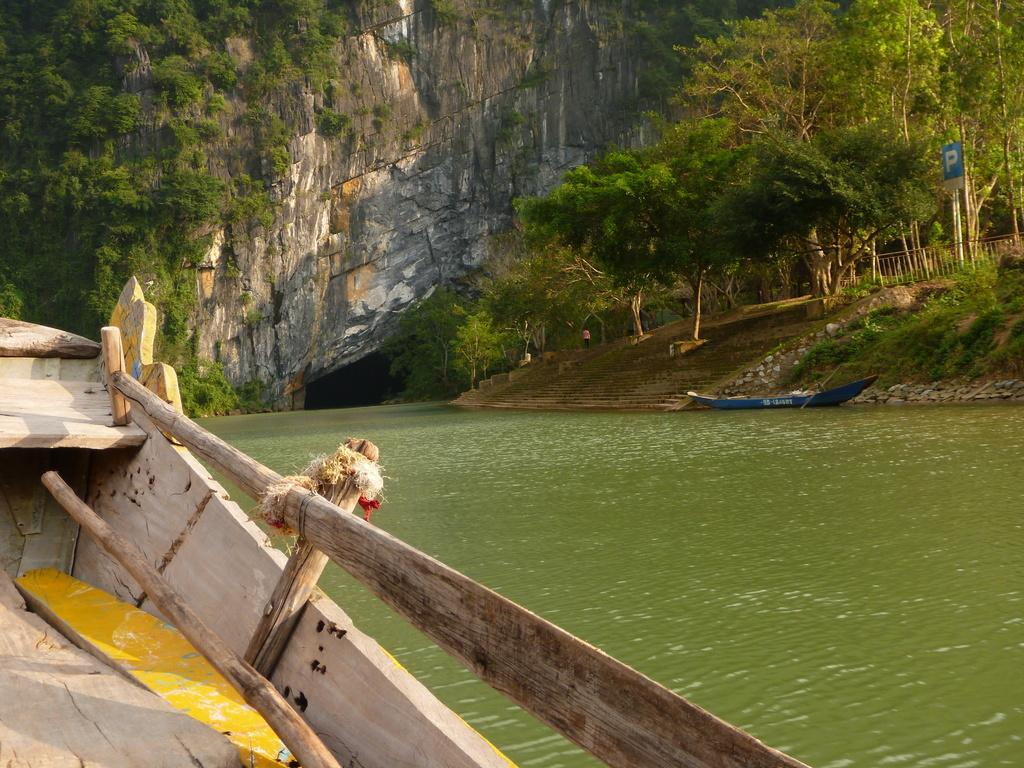What can be seen in the image that is used for transportation on water? There are boats in the image that are used for transportation on water. Where are the boats located in the image? The boats are on the water in the image. What can be seen in the background of the image? In the background of the image, there is a railing, a board, many trees, and a mountain. How many times do the trees in the background laugh in the image? Trees do not laugh, as they are inanimate objects. The question is absurd because it assumes that trees can laugh, which is not possible. 